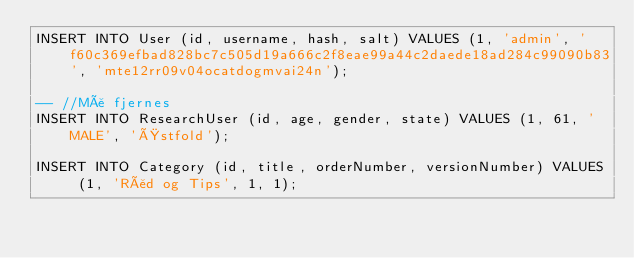Convert code to text. <code><loc_0><loc_0><loc_500><loc_500><_SQL_>INSERT INTO User (id, username, hash, salt) VALUES (1, 'admin', 'f60c369efbad828bc7c505d19a666c2f8eae99a44c2daede18ad284c99090b83', 'mte12rr09v04ocatdogmvai24n');

-- //Må fjernes
INSERT INTO ResearchUser (id, age, gender, state) VALUES (1, 61, 'MALE', 'Østfold');

INSERT INTO Category (id, title, orderNumber, versionNumber) VALUES (1, 'Råd og Tips', 1, 1);</code> 